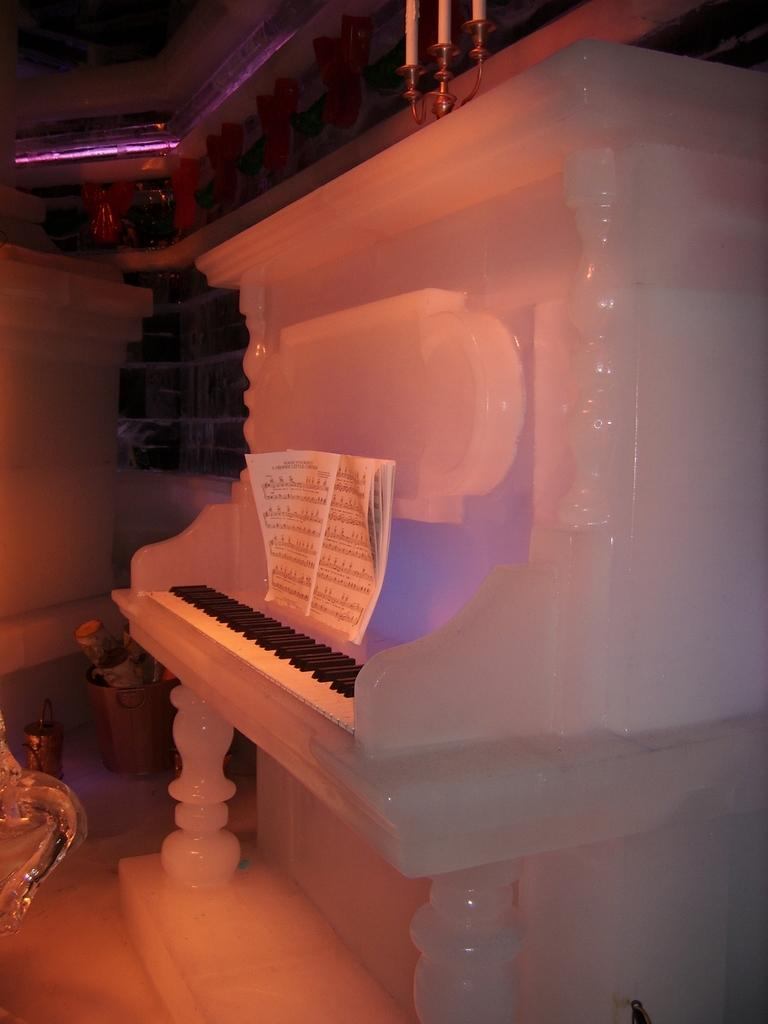What type of musical instrument is in the image? There is a piano in the image. What color is the piano? The piano is white in color. What is placed on top of the piano? There is a book on the piano. What is the purpose of the book on the piano? Music is printed on the book, suggesting it is a sheet music book. What else can be seen in the image related to music? There is a keyboard in the image. What can be seen in the background of the image? There are objects on the floor in the background of the image. What type of industry is represented by the committee in the image? There is no committee or industry present in the image; it features a piano, a book, and a keyboard. 